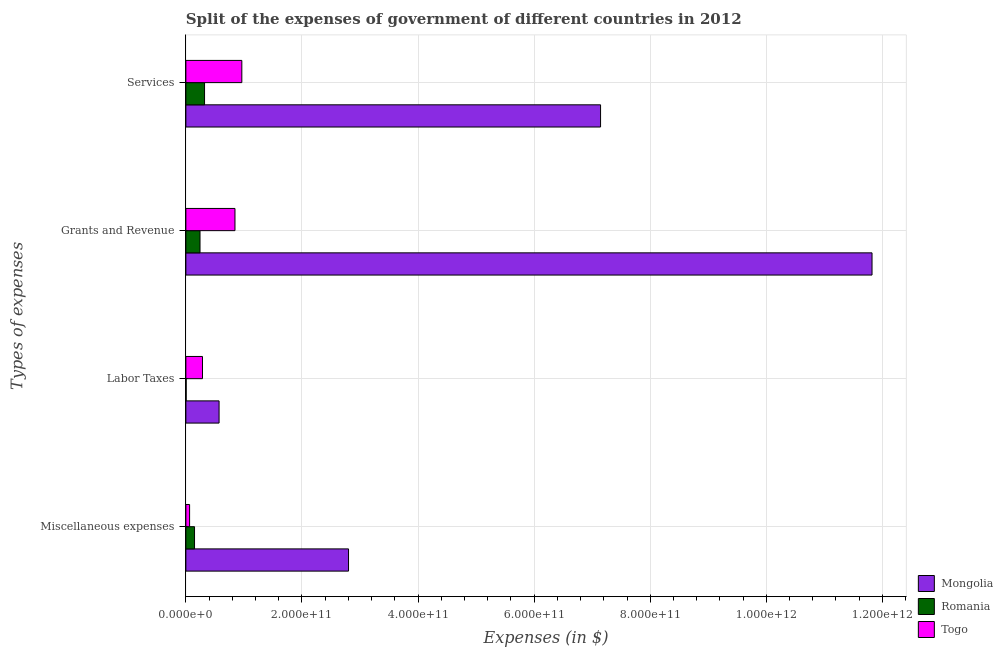How many different coloured bars are there?
Provide a succinct answer. 3. How many groups of bars are there?
Your answer should be very brief. 4. Are the number of bars per tick equal to the number of legend labels?
Keep it short and to the point. Yes. What is the label of the 4th group of bars from the top?
Your answer should be compact. Miscellaneous expenses. What is the amount spent on grants and revenue in Togo?
Your response must be concise. 8.46e+1. Across all countries, what is the maximum amount spent on grants and revenue?
Offer a terse response. 1.18e+12. Across all countries, what is the minimum amount spent on miscellaneous expenses?
Keep it short and to the point. 6.40e+09. In which country was the amount spent on labor taxes maximum?
Your answer should be very brief. Mongolia. In which country was the amount spent on labor taxes minimum?
Give a very brief answer. Romania. What is the total amount spent on labor taxes in the graph?
Your response must be concise. 8.63e+1. What is the difference between the amount spent on labor taxes in Togo and that in Mongolia?
Make the answer very short. -2.86e+1. What is the difference between the amount spent on miscellaneous expenses in Romania and the amount spent on grants and revenue in Mongolia?
Your response must be concise. -1.17e+12. What is the average amount spent on miscellaneous expenses per country?
Give a very brief answer. 1.01e+11. What is the difference between the amount spent on labor taxes and amount spent on miscellaneous expenses in Togo?
Give a very brief answer. 2.22e+1. In how many countries, is the amount spent on miscellaneous expenses greater than 960000000000 $?
Provide a short and direct response. 0. What is the ratio of the amount spent on grants and revenue in Togo to that in Mongolia?
Ensure brevity in your answer.  0.07. Is the amount spent on labor taxes in Togo less than that in Romania?
Provide a short and direct response. No. Is the difference between the amount spent on grants and revenue in Mongolia and Romania greater than the difference between the amount spent on miscellaneous expenses in Mongolia and Romania?
Your answer should be very brief. Yes. What is the difference between the highest and the second highest amount spent on grants and revenue?
Your answer should be compact. 1.10e+12. What is the difference between the highest and the lowest amount spent on labor taxes?
Make the answer very short. 5.67e+1. What does the 1st bar from the top in Grants and Revenue represents?
Ensure brevity in your answer.  Togo. What does the 3rd bar from the bottom in Miscellaneous expenses represents?
Offer a very short reply. Togo. Are all the bars in the graph horizontal?
Your response must be concise. Yes. How many countries are there in the graph?
Provide a short and direct response. 3. What is the difference between two consecutive major ticks on the X-axis?
Offer a terse response. 2.00e+11. Are the values on the major ticks of X-axis written in scientific E-notation?
Provide a succinct answer. Yes. How many legend labels are there?
Your answer should be very brief. 3. How are the legend labels stacked?
Provide a succinct answer. Vertical. What is the title of the graph?
Ensure brevity in your answer.  Split of the expenses of government of different countries in 2012. Does "Afghanistan" appear as one of the legend labels in the graph?
Provide a succinct answer. No. What is the label or title of the X-axis?
Provide a succinct answer. Expenses (in $). What is the label or title of the Y-axis?
Ensure brevity in your answer.  Types of expenses. What is the Expenses (in $) of Mongolia in Miscellaneous expenses?
Your answer should be very brief. 2.80e+11. What is the Expenses (in $) of Romania in Miscellaneous expenses?
Make the answer very short. 1.49e+1. What is the Expenses (in $) of Togo in Miscellaneous expenses?
Your answer should be very brief. 6.40e+09. What is the Expenses (in $) of Mongolia in Labor Taxes?
Your answer should be very brief. 5.72e+1. What is the Expenses (in $) in Romania in Labor Taxes?
Your answer should be compact. 4.90e+08. What is the Expenses (in $) in Togo in Labor Taxes?
Provide a short and direct response. 2.86e+1. What is the Expenses (in $) in Mongolia in Grants and Revenue?
Give a very brief answer. 1.18e+12. What is the Expenses (in $) in Romania in Grants and Revenue?
Give a very brief answer. 2.44e+1. What is the Expenses (in $) in Togo in Grants and Revenue?
Make the answer very short. 8.46e+1. What is the Expenses (in $) of Mongolia in Services?
Your answer should be compact. 7.14e+11. What is the Expenses (in $) of Romania in Services?
Provide a short and direct response. 3.22e+1. What is the Expenses (in $) of Togo in Services?
Your answer should be very brief. 9.64e+1. Across all Types of expenses, what is the maximum Expenses (in $) in Mongolia?
Your answer should be compact. 1.18e+12. Across all Types of expenses, what is the maximum Expenses (in $) in Romania?
Make the answer very short. 3.22e+1. Across all Types of expenses, what is the maximum Expenses (in $) of Togo?
Give a very brief answer. 9.64e+1. Across all Types of expenses, what is the minimum Expenses (in $) of Mongolia?
Provide a succinct answer. 5.72e+1. Across all Types of expenses, what is the minimum Expenses (in $) of Romania?
Your answer should be very brief. 4.90e+08. Across all Types of expenses, what is the minimum Expenses (in $) in Togo?
Keep it short and to the point. 6.40e+09. What is the total Expenses (in $) in Mongolia in the graph?
Provide a succinct answer. 2.23e+12. What is the total Expenses (in $) of Romania in the graph?
Offer a terse response. 7.19e+1. What is the total Expenses (in $) of Togo in the graph?
Ensure brevity in your answer.  2.16e+11. What is the difference between the Expenses (in $) of Mongolia in Miscellaneous expenses and that in Labor Taxes?
Keep it short and to the point. 2.23e+11. What is the difference between the Expenses (in $) of Romania in Miscellaneous expenses and that in Labor Taxes?
Your response must be concise. 1.44e+1. What is the difference between the Expenses (in $) of Togo in Miscellaneous expenses and that in Labor Taxes?
Give a very brief answer. -2.22e+1. What is the difference between the Expenses (in $) in Mongolia in Miscellaneous expenses and that in Grants and Revenue?
Provide a short and direct response. -9.02e+11. What is the difference between the Expenses (in $) of Romania in Miscellaneous expenses and that in Grants and Revenue?
Provide a succinct answer. -9.45e+09. What is the difference between the Expenses (in $) of Togo in Miscellaneous expenses and that in Grants and Revenue?
Give a very brief answer. -7.82e+1. What is the difference between the Expenses (in $) of Mongolia in Miscellaneous expenses and that in Services?
Provide a short and direct response. -4.34e+11. What is the difference between the Expenses (in $) of Romania in Miscellaneous expenses and that in Services?
Offer a very short reply. -1.72e+1. What is the difference between the Expenses (in $) of Togo in Miscellaneous expenses and that in Services?
Your answer should be compact. -9.00e+1. What is the difference between the Expenses (in $) in Mongolia in Labor Taxes and that in Grants and Revenue?
Offer a very short reply. -1.12e+12. What is the difference between the Expenses (in $) of Romania in Labor Taxes and that in Grants and Revenue?
Give a very brief answer. -2.39e+1. What is the difference between the Expenses (in $) in Togo in Labor Taxes and that in Grants and Revenue?
Your answer should be very brief. -5.60e+1. What is the difference between the Expenses (in $) in Mongolia in Labor Taxes and that in Services?
Ensure brevity in your answer.  -6.57e+11. What is the difference between the Expenses (in $) in Romania in Labor Taxes and that in Services?
Give a very brief answer. -3.17e+1. What is the difference between the Expenses (in $) in Togo in Labor Taxes and that in Services?
Ensure brevity in your answer.  -6.78e+1. What is the difference between the Expenses (in $) of Mongolia in Grants and Revenue and that in Services?
Your response must be concise. 4.68e+11. What is the difference between the Expenses (in $) of Romania in Grants and Revenue and that in Services?
Your response must be concise. -7.80e+09. What is the difference between the Expenses (in $) of Togo in Grants and Revenue and that in Services?
Your answer should be compact. -1.18e+1. What is the difference between the Expenses (in $) of Mongolia in Miscellaneous expenses and the Expenses (in $) of Romania in Labor Taxes?
Your answer should be very brief. 2.80e+11. What is the difference between the Expenses (in $) in Mongolia in Miscellaneous expenses and the Expenses (in $) in Togo in Labor Taxes?
Offer a terse response. 2.52e+11. What is the difference between the Expenses (in $) in Romania in Miscellaneous expenses and the Expenses (in $) in Togo in Labor Taxes?
Keep it short and to the point. -1.37e+1. What is the difference between the Expenses (in $) of Mongolia in Miscellaneous expenses and the Expenses (in $) of Romania in Grants and Revenue?
Provide a short and direct response. 2.56e+11. What is the difference between the Expenses (in $) of Mongolia in Miscellaneous expenses and the Expenses (in $) of Togo in Grants and Revenue?
Your response must be concise. 1.96e+11. What is the difference between the Expenses (in $) of Romania in Miscellaneous expenses and the Expenses (in $) of Togo in Grants and Revenue?
Provide a short and direct response. -6.97e+1. What is the difference between the Expenses (in $) in Mongolia in Miscellaneous expenses and the Expenses (in $) in Romania in Services?
Your answer should be very brief. 2.48e+11. What is the difference between the Expenses (in $) in Mongolia in Miscellaneous expenses and the Expenses (in $) in Togo in Services?
Provide a short and direct response. 1.84e+11. What is the difference between the Expenses (in $) in Romania in Miscellaneous expenses and the Expenses (in $) in Togo in Services?
Give a very brief answer. -8.15e+1. What is the difference between the Expenses (in $) in Mongolia in Labor Taxes and the Expenses (in $) in Romania in Grants and Revenue?
Ensure brevity in your answer.  3.28e+1. What is the difference between the Expenses (in $) in Mongolia in Labor Taxes and the Expenses (in $) in Togo in Grants and Revenue?
Provide a short and direct response. -2.74e+1. What is the difference between the Expenses (in $) in Romania in Labor Taxes and the Expenses (in $) in Togo in Grants and Revenue?
Offer a terse response. -8.41e+1. What is the difference between the Expenses (in $) of Mongolia in Labor Taxes and the Expenses (in $) of Romania in Services?
Provide a short and direct response. 2.50e+1. What is the difference between the Expenses (in $) of Mongolia in Labor Taxes and the Expenses (in $) of Togo in Services?
Provide a short and direct response. -3.92e+1. What is the difference between the Expenses (in $) in Romania in Labor Taxes and the Expenses (in $) in Togo in Services?
Provide a succinct answer. -9.59e+1. What is the difference between the Expenses (in $) of Mongolia in Grants and Revenue and the Expenses (in $) of Romania in Services?
Make the answer very short. 1.15e+12. What is the difference between the Expenses (in $) of Mongolia in Grants and Revenue and the Expenses (in $) of Togo in Services?
Offer a terse response. 1.09e+12. What is the difference between the Expenses (in $) in Romania in Grants and Revenue and the Expenses (in $) in Togo in Services?
Your answer should be very brief. -7.20e+1. What is the average Expenses (in $) in Mongolia per Types of expenses?
Offer a very short reply. 5.58e+11. What is the average Expenses (in $) in Romania per Types of expenses?
Provide a succinct answer. 1.80e+1. What is the average Expenses (in $) in Togo per Types of expenses?
Your response must be concise. 5.40e+1. What is the difference between the Expenses (in $) in Mongolia and Expenses (in $) in Romania in Miscellaneous expenses?
Keep it short and to the point. 2.65e+11. What is the difference between the Expenses (in $) in Mongolia and Expenses (in $) in Togo in Miscellaneous expenses?
Your response must be concise. 2.74e+11. What is the difference between the Expenses (in $) in Romania and Expenses (in $) in Togo in Miscellaneous expenses?
Your answer should be compact. 8.51e+09. What is the difference between the Expenses (in $) in Mongolia and Expenses (in $) in Romania in Labor Taxes?
Ensure brevity in your answer.  5.67e+1. What is the difference between the Expenses (in $) of Mongolia and Expenses (in $) of Togo in Labor Taxes?
Your answer should be compact. 2.86e+1. What is the difference between the Expenses (in $) of Romania and Expenses (in $) of Togo in Labor Taxes?
Your answer should be compact. -2.81e+1. What is the difference between the Expenses (in $) in Mongolia and Expenses (in $) in Romania in Grants and Revenue?
Your answer should be compact. 1.16e+12. What is the difference between the Expenses (in $) of Mongolia and Expenses (in $) of Togo in Grants and Revenue?
Offer a very short reply. 1.10e+12. What is the difference between the Expenses (in $) of Romania and Expenses (in $) of Togo in Grants and Revenue?
Ensure brevity in your answer.  -6.02e+1. What is the difference between the Expenses (in $) in Mongolia and Expenses (in $) in Romania in Services?
Provide a short and direct response. 6.82e+11. What is the difference between the Expenses (in $) of Mongolia and Expenses (in $) of Togo in Services?
Make the answer very short. 6.18e+11. What is the difference between the Expenses (in $) in Romania and Expenses (in $) in Togo in Services?
Your response must be concise. -6.42e+1. What is the ratio of the Expenses (in $) of Mongolia in Miscellaneous expenses to that in Labor Taxes?
Keep it short and to the point. 4.9. What is the ratio of the Expenses (in $) in Romania in Miscellaneous expenses to that in Labor Taxes?
Ensure brevity in your answer.  30.47. What is the ratio of the Expenses (in $) of Togo in Miscellaneous expenses to that in Labor Taxes?
Your answer should be very brief. 0.22. What is the ratio of the Expenses (in $) of Mongolia in Miscellaneous expenses to that in Grants and Revenue?
Provide a succinct answer. 0.24. What is the ratio of the Expenses (in $) of Romania in Miscellaneous expenses to that in Grants and Revenue?
Offer a terse response. 0.61. What is the ratio of the Expenses (in $) in Togo in Miscellaneous expenses to that in Grants and Revenue?
Give a very brief answer. 0.08. What is the ratio of the Expenses (in $) in Mongolia in Miscellaneous expenses to that in Services?
Make the answer very short. 0.39. What is the ratio of the Expenses (in $) of Romania in Miscellaneous expenses to that in Services?
Provide a succinct answer. 0.46. What is the ratio of the Expenses (in $) of Togo in Miscellaneous expenses to that in Services?
Provide a succinct answer. 0.07. What is the ratio of the Expenses (in $) of Mongolia in Labor Taxes to that in Grants and Revenue?
Make the answer very short. 0.05. What is the ratio of the Expenses (in $) in Romania in Labor Taxes to that in Grants and Revenue?
Provide a short and direct response. 0.02. What is the ratio of the Expenses (in $) in Togo in Labor Taxes to that in Grants and Revenue?
Your answer should be compact. 0.34. What is the ratio of the Expenses (in $) of Romania in Labor Taxes to that in Services?
Your response must be concise. 0.02. What is the ratio of the Expenses (in $) in Togo in Labor Taxes to that in Services?
Provide a short and direct response. 0.3. What is the ratio of the Expenses (in $) in Mongolia in Grants and Revenue to that in Services?
Give a very brief answer. 1.65. What is the ratio of the Expenses (in $) of Romania in Grants and Revenue to that in Services?
Offer a terse response. 0.76. What is the ratio of the Expenses (in $) of Togo in Grants and Revenue to that in Services?
Give a very brief answer. 0.88. What is the difference between the highest and the second highest Expenses (in $) in Mongolia?
Offer a very short reply. 4.68e+11. What is the difference between the highest and the second highest Expenses (in $) of Romania?
Keep it short and to the point. 7.80e+09. What is the difference between the highest and the second highest Expenses (in $) of Togo?
Make the answer very short. 1.18e+1. What is the difference between the highest and the lowest Expenses (in $) of Mongolia?
Ensure brevity in your answer.  1.12e+12. What is the difference between the highest and the lowest Expenses (in $) of Romania?
Provide a succinct answer. 3.17e+1. What is the difference between the highest and the lowest Expenses (in $) of Togo?
Your response must be concise. 9.00e+1. 